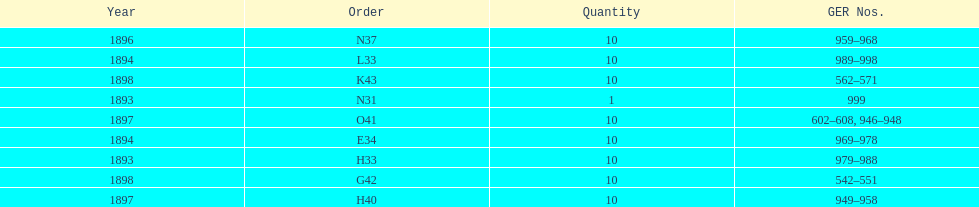Which year between 1893 and 1898 was there not an order? 1895. 